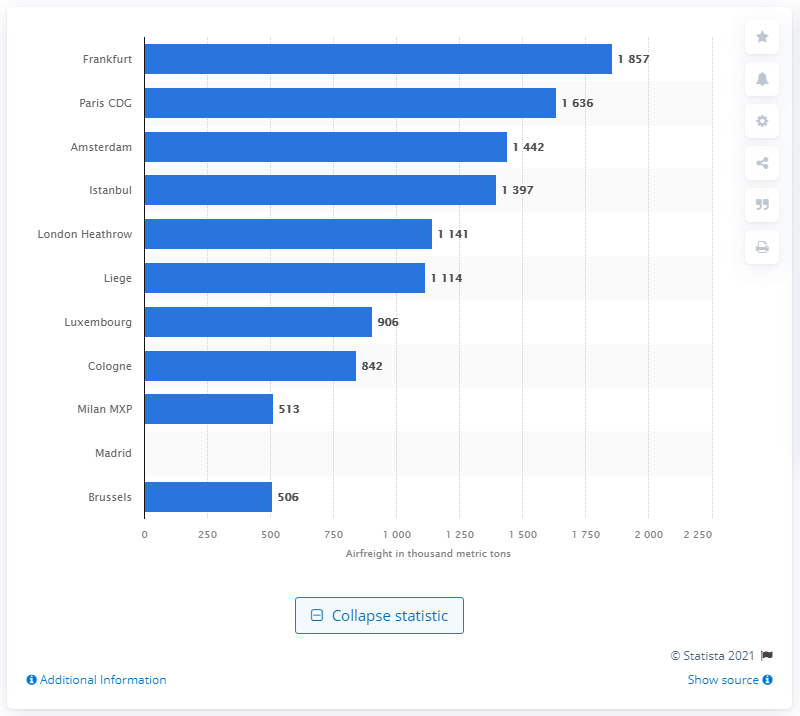Identify some key points in this picture. According to data, Frankfurt Airport was the European airport that handled the most airfreight in 2020. 